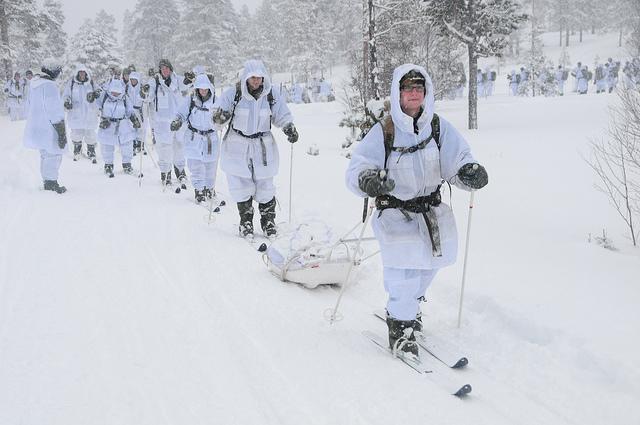What relation does the clothes here have?
Select the correct answer and articulate reasoning with the following format: 'Answer: answer
Rationale: rationale.'
Options: Opposites, uniforms, all unrelated, summer clothes. Answer: uniforms.
Rationale: The relation is the uniform. 